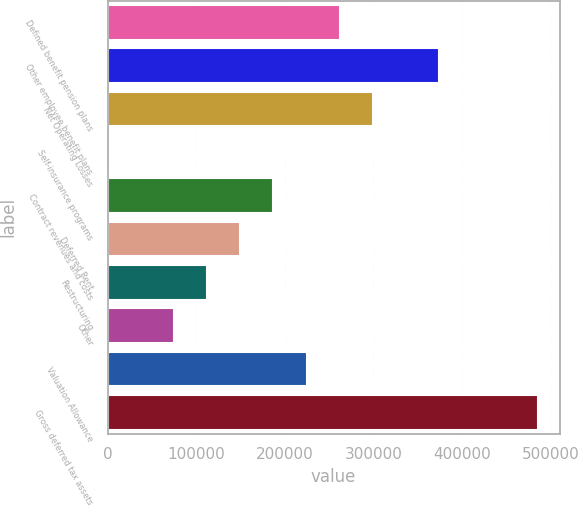<chart> <loc_0><loc_0><loc_500><loc_500><bar_chart><fcel>Defined benefit pension plans<fcel>Other employee benefit plans<fcel>Net Operating Losses<fcel>Self-insurance programs<fcel>Contract revenues and costs<fcel>Deferred Rent<fcel>Restructuring<fcel>Other<fcel>Valuation Allowance<fcel>Gross deferred tax assets<nl><fcel>261987<fcel>374064<fcel>299346<fcel>473<fcel>187268<fcel>149909<fcel>112550<fcel>75191.2<fcel>224628<fcel>486141<nl></chart> 